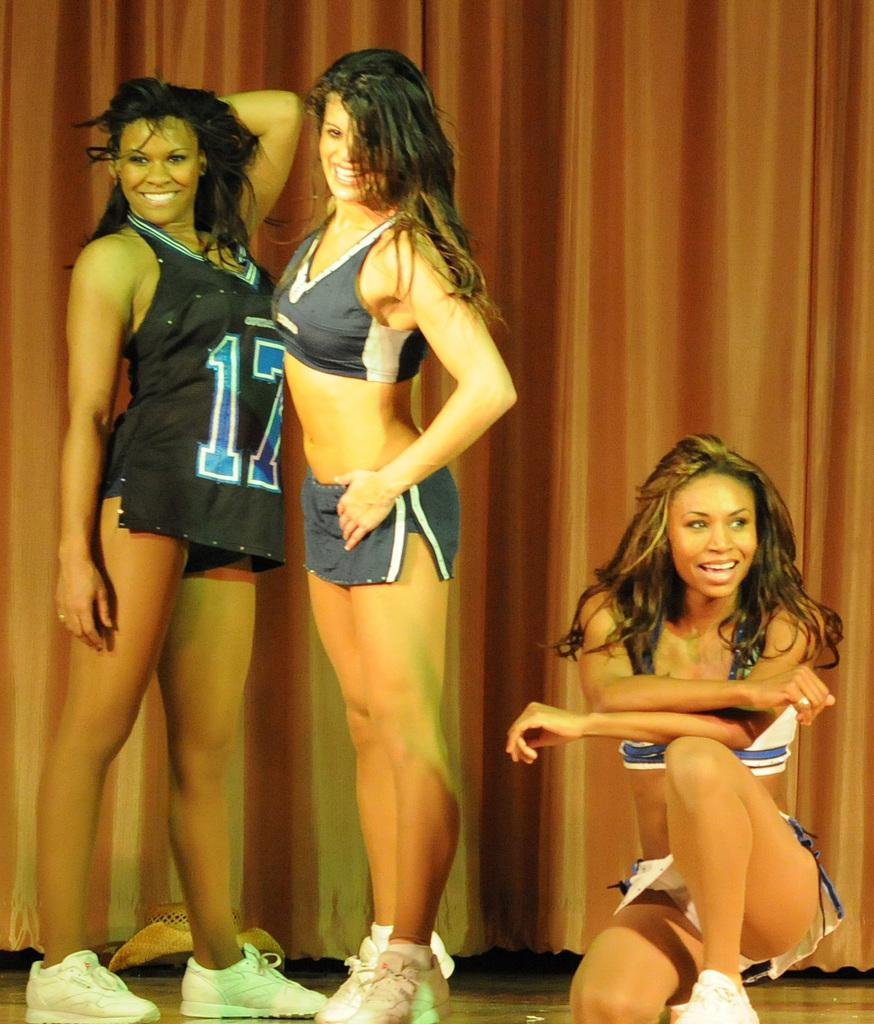<image>
Create a compact narrative representing the image presented. Cheerleaders, one wearing number 17, pose for a picture. 